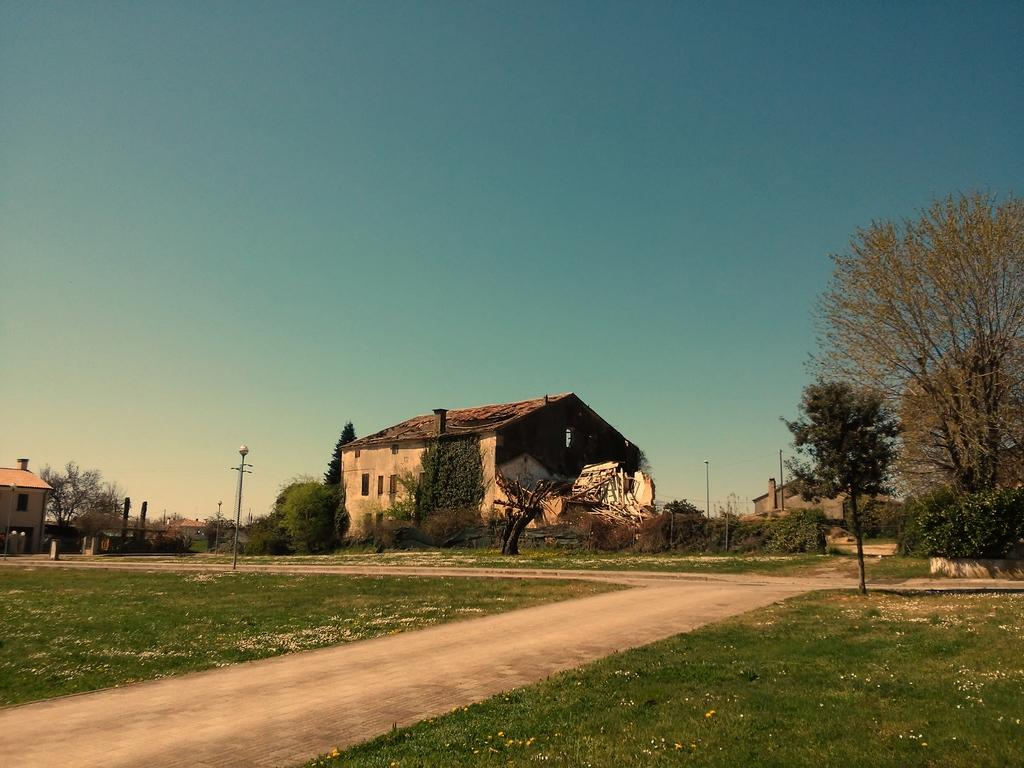What is the main feature of the image? There is a road in the image. What can be seen on both sides of the road? Grass is present on both sides of the road. What is visible in the background of the image? There are trees, plants, and buildings in the background of the image. What is the color of the sky in the image? The sky is blue in the image. Where is the library located in the image? There is no library present in the image. Can you tell me how many aunts are walking on the slope in the image? There is no slope or aunt present in the image. 